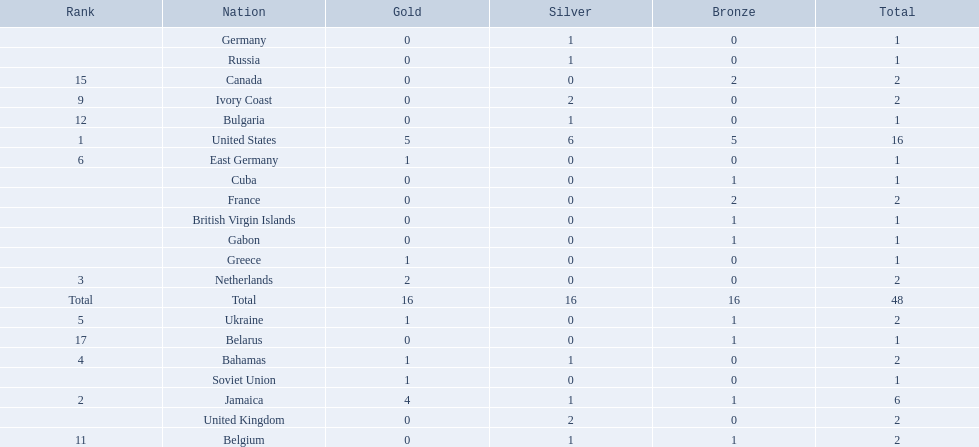Which countries participated? United States, Jamaica, Netherlands, Bahamas, Ukraine, East Germany, Greece, Soviet Union, Ivory Coast, United Kingdom, Belgium, Bulgaria, Russia, Germany, Canada, France, Belarus, Cuba, Gabon, British Virgin Islands. Can you give me this table as a dict? {'header': ['Rank', 'Nation', 'Gold', 'Silver', 'Bronze', 'Total'], 'rows': [['', 'Germany', '0', '1', '0', '1'], ['', 'Russia', '0', '1', '0', '1'], ['15', 'Canada', '0', '0', '2', '2'], ['9', 'Ivory Coast', '0', '2', '0', '2'], ['12', 'Bulgaria', '0', '1', '0', '1'], ['1', 'United States', '5', '6', '5', '16'], ['6', 'East Germany', '1', '0', '0', '1'], ['', 'Cuba', '0', '0', '1', '1'], ['', 'France', '0', '0', '2', '2'], ['', 'British Virgin Islands', '0', '0', '1', '1'], ['', 'Gabon', '0', '0', '1', '1'], ['', 'Greece', '1', '0', '0', '1'], ['3', 'Netherlands', '2', '0', '0', '2'], ['Total', 'Total', '16', '16', '16', '48'], ['5', 'Ukraine', '1', '0', '1', '2'], ['17', 'Belarus', '0', '0', '1', '1'], ['4', 'Bahamas', '1', '1', '0', '2'], ['', 'Soviet Union', '1', '0', '0', '1'], ['2', 'Jamaica', '4', '1', '1', '6'], ['', 'United Kingdom', '0', '2', '0', '2'], ['11', 'Belgium', '0', '1', '1', '2']]} How many gold medals were won by each? 5, 4, 2, 1, 1, 1, 1, 1, 0, 0, 0, 0, 0, 0, 0, 0, 0, 0, 0, 0. And which country won the most? United States. 